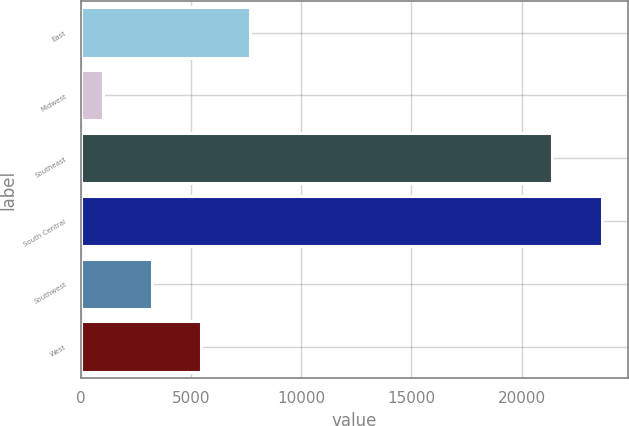<chart> <loc_0><loc_0><loc_500><loc_500><bar_chart><fcel>East<fcel>Midwest<fcel>Southeast<fcel>South Central<fcel>Southwest<fcel>West<nl><fcel>7690<fcel>1000<fcel>21400<fcel>23630<fcel>3230<fcel>5460<nl></chart> 